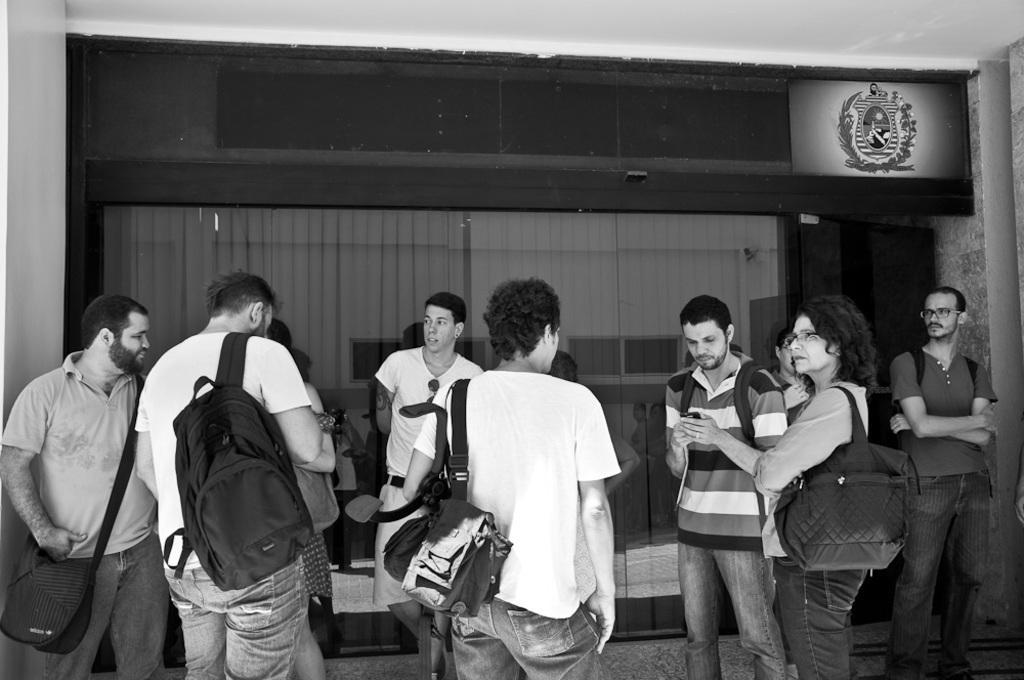In one or two sentences, can you explain what this image depicts? In this black and white image, we can see people standing in front of the cabin. There are some people wearing bags. There is a ceiling at the top of the image. 